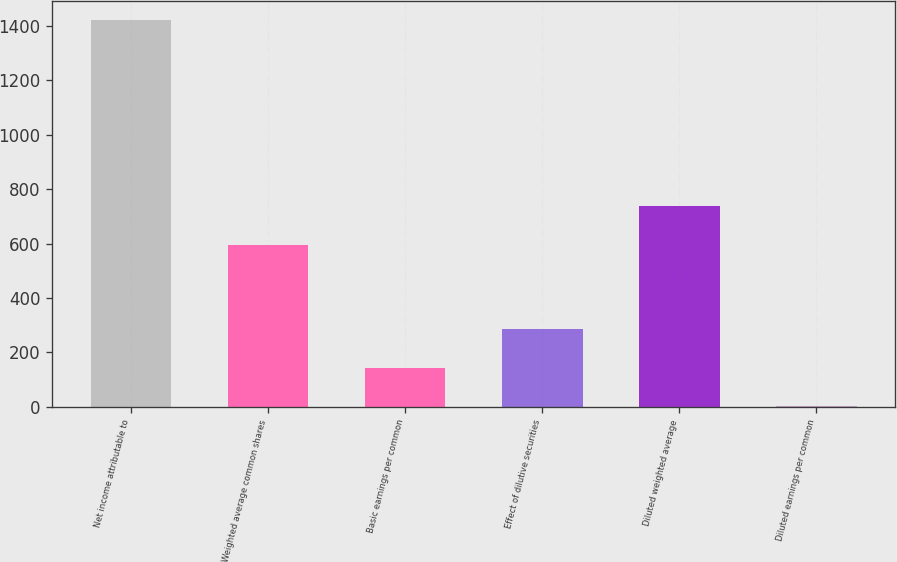<chart> <loc_0><loc_0><loc_500><loc_500><bar_chart><fcel>Net income attributable to<fcel>Weighted average common shares<fcel>Basic earnings per common<fcel>Effect of dilutive securities<fcel>Diluted weighted average<fcel>Diluted earnings per common<nl><fcel>1422<fcel>595<fcel>144.33<fcel>286.29<fcel>736.96<fcel>2.37<nl></chart> 